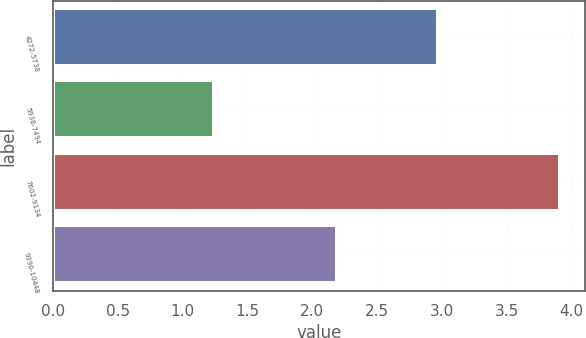Convert chart. <chart><loc_0><loc_0><loc_500><loc_500><bar_chart><fcel>4272-5738<fcel>5938-7494<fcel>7602-9134<fcel>9390-10448<nl><fcel>2.97<fcel>1.24<fcel>3.91<fcel>2.19<nl></chart> 